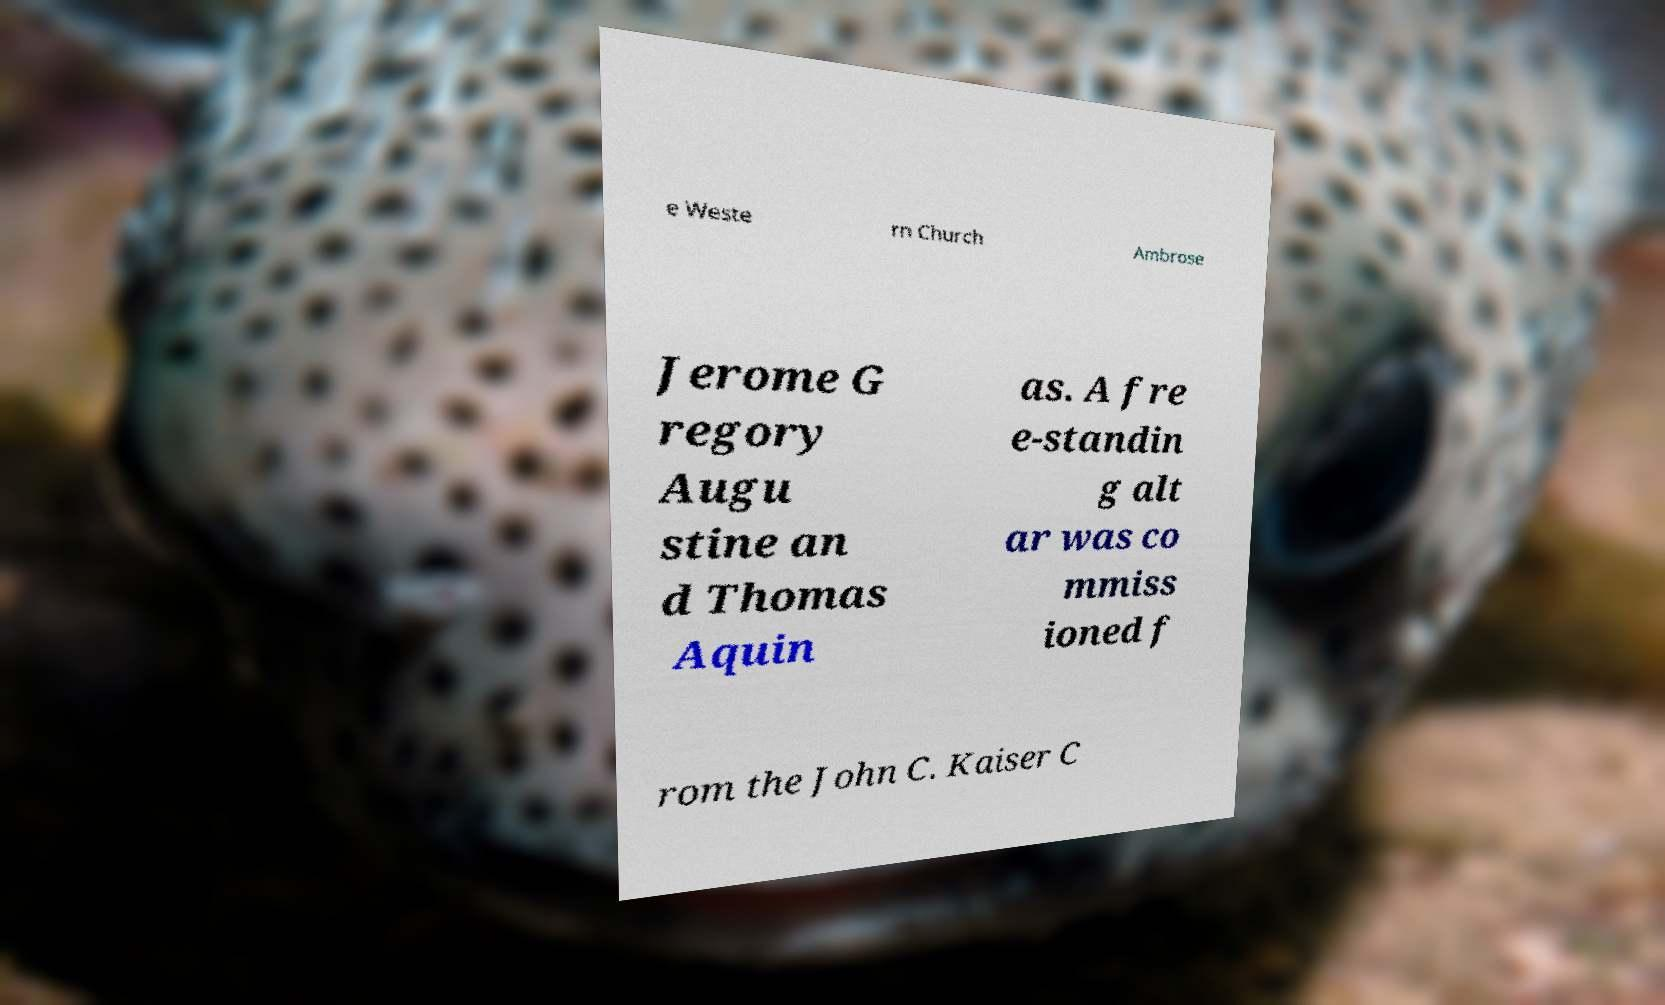For documentation purposes, I need the text within this image transcribed. Could you provide that? e Weste rn Church Ambrose Jerome G regory Augu stine an d Thomas Aquin as. A fre e-standin g alt ar was co mmiss ioned f rom the John C. Kaiser C 